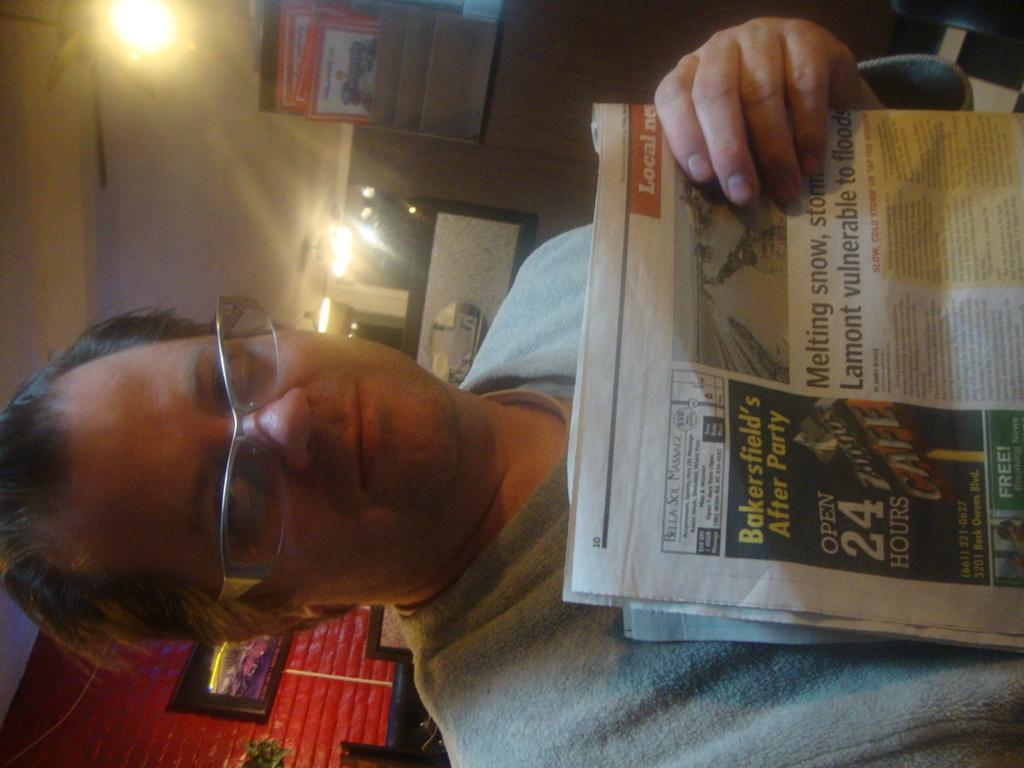Who is present in the image? There is a man in the image. What is the man doing in the image? The man is standing in the image. What is the man holding in the image? The man is holding a paper in the image. What can be seen behind the man in the image? There is a wall behind the man in the image. What is on the wall in the image? There are frames on the wall in the image, and there is light visible on the wall. What type of wound can be seen on the man's arm in the image? There is no wound visible on the man's arm in the image. What type of furniture is present in the image? The provided facts do not mention any furniture in the image. 